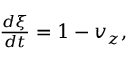<formula> <loc_0><loc_0><loc_500><loc_500>\begin{array} { r } { \frac { d \xi } { d t } = 1 - v _ { z } , } \end{array}</formula> 